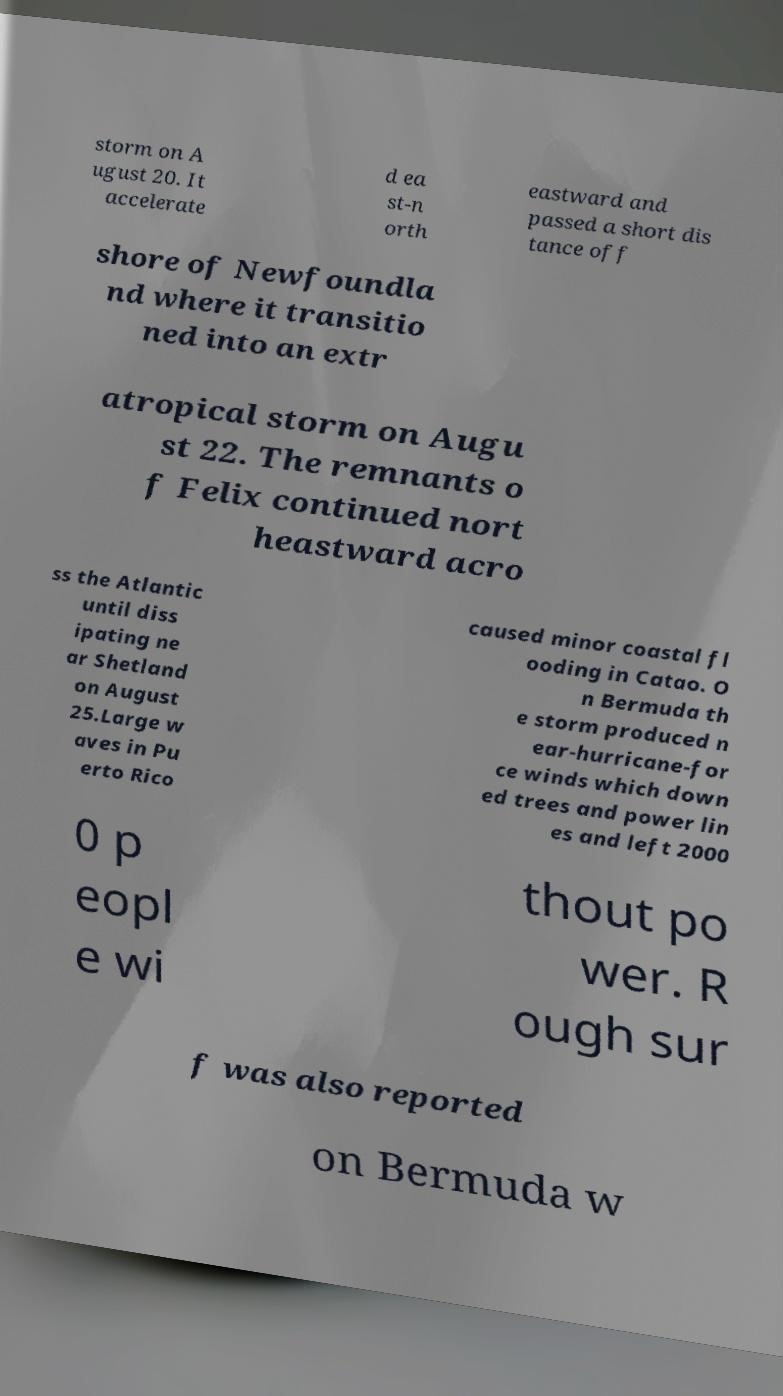What messages or text are displayed in this image? I need them in a readable, typed format. storm on A ugust 20. It accelerate d ea st-n orth eastward and passed a short dis tance off shore of Newfoundla nd where it transitio ned into an extr atropical storm on Augu st 22. The remnants o f Felix continued nort heastward acro ss the Atlantic until diss ipating ne ar Shetland on August 25.Large w aves in Pu erto Rico caused minor coastal fl ooding in Catao. O n Bermuda th e storm produced n ear-hurricane-for ce winds which down ed trees and power lin es and left 2000 0 p eopl e wi thout po wer. R ough sur f was also reported on Bermuda w 